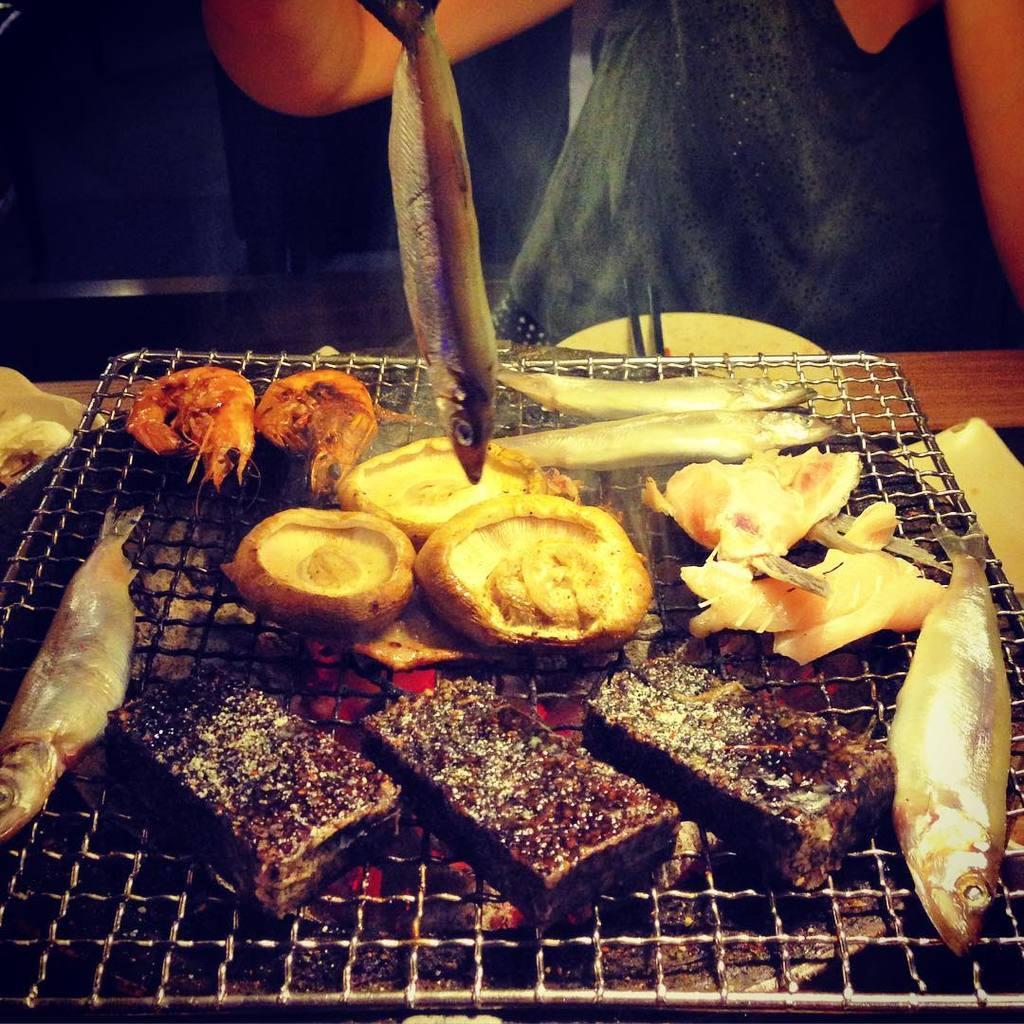Describe this image in one or two sentences. In this picture there are some mutton pieces, fish and crabs are placed on the barbecue grill. 